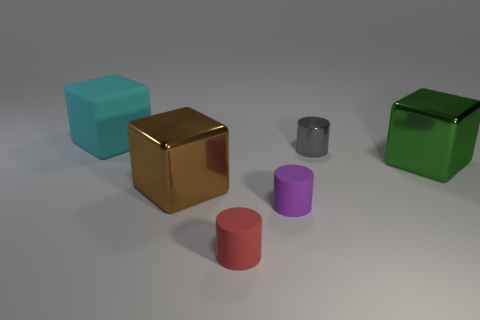Do the brown metallic object and the large cyan rubber object have the same shape?
Provide a succinct answer. Yes. There is another rubber cylinder that is the same size as the purple matte cylinder; what color is it?
Your answer should be very brief. Red. What is the size of the brown object that is the same shape as the green metallic thing?
Your answer should be very brief. Large. What is the shape of the shiny thing that is on the left side of the purple thing?
Provide a succinct answer. Cube. Do the tiny purple thing and the metal object that is in front of the green thing have the same shape?
Keep it short and to the point. No. Are there an equal number of cyan rubber objects in front of the big brown cube and purple cylinders that are on the left side of the tiny red rubber cylinder?
Your answer should be very brief. Yes. There is a tiny matte object behind the red cylinder; is it the same color as the big thing that is behind the small gray shiny cylinder?
Make the answer very short. No. Are there more big cyan matte blocks that are on the right side of the cyan block than tiny rubber cylinders?
Provide a succinct answer. No. What material is the red object?
Keep it short and to the point. Rubber. There is a tiny purple object that is made of the same material as the big cyan cube; what is its shape?
Your response must be concise. Cylinder. 